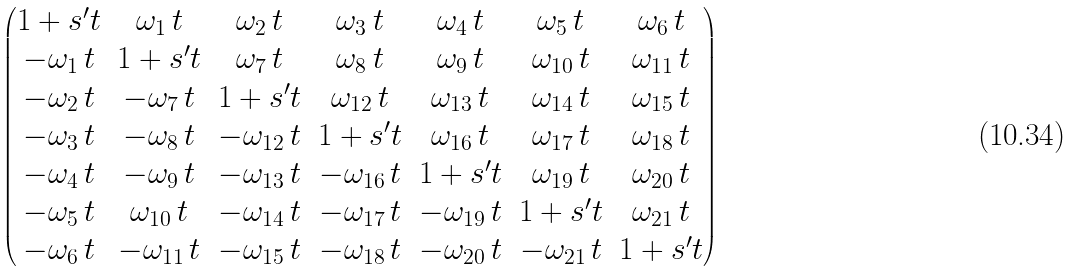Convert formula to latex. <formula><loc_0><loc_0><loc_500><loc_500>\begin{pmatrix} 1 + s ^ { \prime } t & \omega _ { 1 } \, t & \omega _ { 2 } \, t & \omega _ { 3 } \, t & \omega _ { 4 } \, t & \omega _ { 5 } \, t & \omega _ { 6 } \, t \\ - \omega _ { 1 } \, t & 1 + s ^ { \prime } t & \omega _ { 7 } \, t & \omega _ { 8 } \, t & \omega _ { 9 } \, t & \omega _ { 1 0 } \, t & \omega _ { 1 1 } \, t \\ - \omega _ { 2 } \, t & - \omega _ { 7 } \, t & 1 + s ^ { \prime } t & \omega _ { 1 2 } \, t & \omega _ { 1 3 } \, t & \omega _ { 1 4 } \, t & \omega _ { 1 5 } \, t \\ - \omega _ { 3 } \, t & - \omega _ { 8 } \, t & - \omega _ { 1 2 } \, t & 1 + s ^ { \prime } t & \omega _ { 1 6 } \, t & \omega _ { 1 7 } \, t & \omega _ { 1 8 } \, t \\ - \omega _ { 4 } \, t & - \omega _ { 9 } \, t & - \omega _ { 1 3 } \, t & - \omega _ { 1 6 } \, t & 1 + s ^ { \prime } t & \omega _ { 1 9 } \, t & \omega _ { 2 0 } \, t \\ - \omega _ { 5 } \, t & \omega _ { 1 0 } \, t & - \omega _ { 1 4 } \, t & - \omega _ { 1 7 } \, t & - \omega _ { 1 9 } \, t & 1 + s ^ { \prime } t & \omega _ { 2 1 } \, t \\ - \omega _ { 6 } \, t & - \omega _ { 1 1 } \, t & - \omega _ { 1 5 } \, t & - \omega _ { 1 8 } \, t & - \omega _ { 2 0 } \, t & - \omega _ { 2 1 } \, t & 1 + s ^ { \prime } t \end{pmatrix}</formula> 